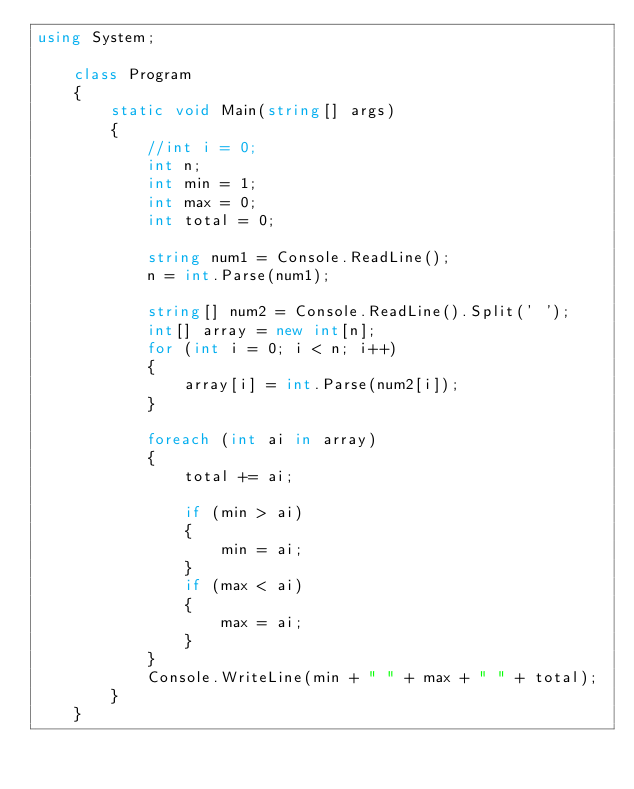<code> <loc_0><loc_0><loc_500><loc_500><_C#_>using System;

    class Program
    {
        static void Main(string[] args)
        {
            //int i = 0;
            int n;
            int min = 1;
            int max = 0;
            int total = 0;

            string num1 = Console.ReadLine();
            n = int.Parse(num1);

            string[] num2 = Console.ReadLine().Split(' ');
            int[] array = new int[n];
            for (int i = 0; i < n; i++)
            {
                array[i] = int.Parse(num2[i]);
            }
            
            foreach (int ai in array)
            {
                total += ai;

                if (min > ai)
                {
                    min = ai;
                }
                if (max < ai)
                {
                    max = ai;
                }
            }
            Console.WriteLine(min + " " + max + " " + total);
        }
    }

</code> 